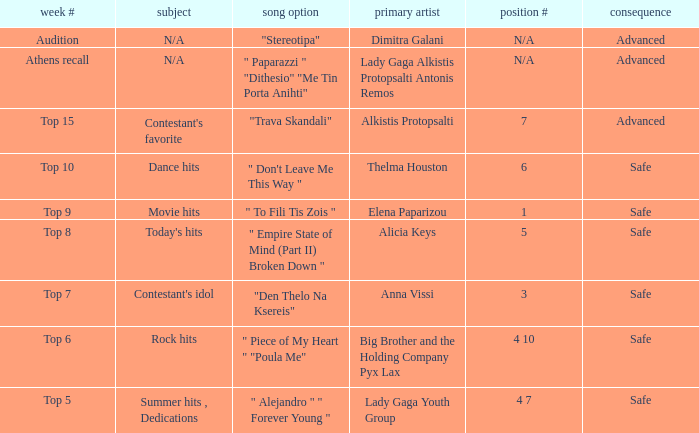Which artists have order number 6? Thelma Houston. 